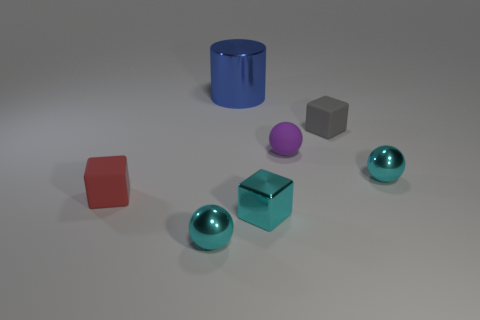Are there any other things that are the same size as the blue metal cylinder?
Ensure brevity in your answer.  No. Are there more gray objects that are on the right side of the small gray rubber object than tiny blocks on the left side of the blue metallic object?
Ensure brevity in your answer.  No. There is a gray object that is made of the same material as the tiny purple ball; what is its shape?
Make the answer very short. Cube. Is the number of purple balls that are in front of the purple ball greater than the number of red objects?
Give a very brief answer. No. What number of spheres are the same color as the shiny block?
Your answer should be compact. 2. What number of other things are the same color as the shiny cube?
Ensure brevity in your answer.  2. Is the number of tiny rubber spheres greater than the number of cyan balls?
Offer a very short reply. No. What material is the large cylinder?
Keep it short and to the point. Metal. Is the size of the blue metal object behind the red matte thing the same as the small purple rubber object?
Keep it short and to the point. No. There is a shiny object behind the matte ball; what is its size?
Offer a very short reply. Large. 